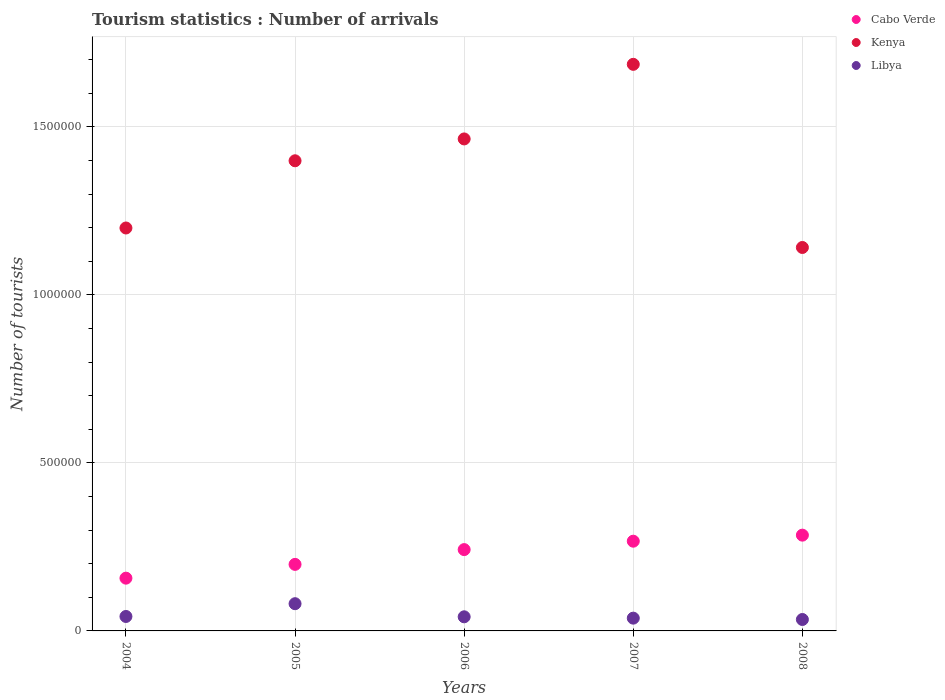Is the number of dotlines equal to the number of legend labels?
Your answer should be compact. Yes. What is the number of tourist arrivals in Libya in 2006?
Ensure brevity in your answer.  4.20e+04. Across all years, what is the maximum number of tourist arrivals in Kenya?
Provide a short and direct response. 1.69e+06. Across all years, what is the minimum number of tourist arrivals in Cabo Verde?
Offer a very short reply. 1.57e+05. What is the total number of tourist arrivals in Libya in the graph?
Make the answer very short. 2.38e+05. What is the difference between the number of tourist arrivals in Libya in 2006 and the number of tourist arrivals in Kenya in 2007?
Your answer should be compact. -1.64e+06. What is the average number of tourist arrivals in Kenya per year?
Provide a short and direct response. 1.38e+06. In the year 2006, what is the difference between the number of tourist arrivals in Kenya and number of tourist arrivals in Libya?
Your answer should be compact. 1.42e+06. In how many years, is the number of tourist arrivals in Kenya greater than 1100000?
Make the answer very short. 5. What is the ratio of the number of tourist arrivals in Kenya in 2004 to that in 2006?
Your response must be concise. 0.82. Is the number of tourist arrivals in Cabo Verde in 2006 less than that in 2007?
Keep it short and to the point. Yes. Is the difference between the number of tourist arrivals in Kenya in 2005 and 2007 greater than the difference between the number of tourist arrivals in Libya in 2005 and 2007?
Your answer should be compact. No. What is the difference between the highest and the second highest number of tourist arrivals in Kenya?
Provide a short and direct response. 2.22e+05. What is the difference between the highest and the lowest number of tourist arrivals in Cabo Verde?
Provide a succinct answer. 1.28e+05. In how many years, is the number of tourist arrivals in Kenya greater than the average number of tourist arrivals in Kenya taken over all years?
Your response must be concise. 3. How many dotlines are there?
Your answer should be very brief. 3. How many years are there in the graph?
Ensure brevity in your answer.  5. How are the legend labels stacked?
Keep it short and to the point. Vertical. What is the title of the graph?
Keep it short and to the point. Tourism statistics : Number of arrivals. Does "Niger" appear as one of the legend labels in the graph?
Offer a very short reply. No. What is the label or title of the X-axis?
Offer a terse response. Years. What is the label or title of the Y-axis?
Your response must be concise. Number of tourists. What is the Number of tourists of Cabo Verde in 2004?
Provide a succinct answer. 1.57e+05. What is the Number of tourists of Kenya in 2004?
Make the answer very short. 1.20e+06. What is the Number of tourists in Libya in 2004?
Provide a succinct answer. 4.30e+04. What is the Number of tourists of Cabo Verde in 2005?
Your answer should be compact. 1.98e+05. What is the Number of tourists in Kenya in 2005?
Offer a terse response. 1.40e+06. What is the Number of tourists of Libya in 2005?
Keep it short and to the point. 8.10e+04. What is the Number of tourists of Cabo Verde in 2006?
Keep it short and to the point. 2.42e+05. What is the Number of tourists in Kenya in 2006?
Make the answer very short. 1.46e+06. What is the Number of tourists of Libya in 2006?
Offer a terse response. 4.20e+04. What is the Number of tourists of Cabo Verde in 2007?
Ensure brevity in your answer.  2.67e+05. What is the Number of tourists of Kenya in 2007?
Keep it short and to the point. 1.69e+06. What is the Number of tourists in Libya in 2007?
Ensure brevity in your answer.  3.80e+04. What is the Number of tourists of Cabo Verde in 2008?
Provide a succinct answer. 2.85e+05. What is the Number of tourists in Kenya in 2008?
Offer a very short reply. 1.14e+06. What is the Number of tourists in Libya in 2008?
Make the answer very short. 3.40e+04. Across all years, what is the maximum Number of tourists in Cabo Verde?
Your answer should be compact. 2.85e+05. Across all years, what is the maximum Number of tourists of Kenya?
Give a very brief answer. 1.69e+06. Across all years, what is the maximum Number of tourists in Libya?
Offer a very short reply. 8.10e+04. Across all years, what is the minimum Number of tourists in Cabo Verde?
Ensure brevity in your answer.  1.57e+05. Across all years, what is the minimum Number of tourists of Kenya?
Provide a succinct answer. 1.14e+06. Across all years, what is the minimum Number of tourists in Libya?
Offer a very short reply. 3.40e+04. What is the total Number of tourists of Cabo Verde in the graph?
Offer a terse response. 1.15e+06. What is the total Number of tourists of Kenya in the graph?
Provide a succinct answer. 6.89e+06. What is the total Number of tourists in Libya in the graph?
Your response must be concise. 2.38e+05. What is the difference between the Number of tourists of Cabo Verde in 2004 and that in 2005?
Provide a succinct answer. -4.10e+04. What is the difference between the Number of tourists in Libya in 2004 and that in 2005?
Keep it short and to the point. -3.80e+04. What is the difference between the Number of tourists in Cabo Verde in 2004 and that in 2006?
Your answer should be very brief. -8.50e+04. What is the difference between the Number of tourists in Kenya in 2004 and that in 2006?
Your answer should be compact. -2.65e+05. What is the difference between the Number of tourists in Libya in 2004 and that in 2006?
Provide a short and direct response. 1000. What is the difference between the Number of tourists in Kenya in 2004 and that in 2007?
Offer a terse response. -4.87e+05. What is the difference between the Number of tourists in Cabo Verde in 2004 and that in 2008?
Give a very brief answer. -1.28e+05. What is the difference between the Number of tourists of Kenya in 2004 and that in 2008?
Ensure brevity in your answer.  5.80e+04. What is the difference between the Number of tourists of Libya in 2004 and that in 2008?
Your answer should be very brief. 9000. What is the difference between the Number of tourists of Cabo Verde in 2005 and that in 2006?
Provide a succinct answer. -4.40e+04. What is the difference between the Number of tourists in Kenya in 2005 and that in 2006?
Provide a succinct answer. -6.50e+04. What is the difference between the Number of tourists of Libya in 2005 and that in 2006?
Offer a terse response. 3.90e+04. What is the difference between the Number of tourists in Cabo Verde in 2005 and that in 2007?
Give a very brief answer. -6.90e+04. What is the difference between the Number of tourists of Kenya in 2005 and that in 2007?
Provide a succinct answer. -2.87e+05. What is the difference between the Number of tourists of Libya in 2005 and that in 2007?
Provide a short and direct response. 4.30e+04. What is the difference between the Number of tourists in Cabo Verde in 2005 and that in 2008?
Offer a terse response. -8.70e+04. What is the difference between the Number of tourists of Kenya in 2005 and that in 2008?
Give a very brief answer. 2.58e+05. What is the difference between the Number of tourists of Libya in 2005 and that in 2008?
Provide a succinct answer. 4.70e+04. What is the difference between the Number of tourists of Cabo Verde in 2006 and that in 2007?
Your answer should be very brief. -2.50e+04. What is the difference between the Number of tourists in Kenya in 2006 and that in 2007?
Make the answer very short. -2.22e+05. What is the difference between the Number of tourists in Libya in 2006 and that in 2007?
Provide a short and direct response. 4000. What is the difference between the Number of tourists in Cabo Verde in 2006 and that in 2008?
Provide a succinct answer. -4.30e+04. What is the difference between the Number of tourists in Kenya in 2006 and that in 2008?
Your response must be concise. 3.23e+05. What is the difference between the Number of tourists of Libya in 2006 and that in 2008?
Your response must be concise. 8000. What is the difference between the Number of tourists of Cabo Verde in 2007 and that in 2008?
Your answer should be very brief. -1.80e+04. What is the difference between the Number of tourists in Kenya in 2007 and that in 2008?
Your answer should be very brief. 5.45e+05. What is the difference between the Number of tourists of Libya in 2007 and that in 2008?
Keep it short and to the point. 4000. What is the difference between the Number of tourists of Cabo Verde in 2004 and the Number of tourists of Kenya in 2005?
Provide a succinct answer. -1.24e+06. What is the difference between the Number of tourists in Cabo Verde in 2004 and the Number of tourists in Libya in 2005?
Ensure brevity in your answer.  7.60e+04. What is the difference between the Number of tourists of Kenya in 2004 and the Number of tourists of Libya in 2005?
Offer a terse response. 1.12e+06. What is the difference between the Number of tourists of Cabo Verde in 2004 and the Number of tourists of Kenya in 2006?
Your answer should be compact. -1.31e+06. What is the difference between the Number of tourists in Cabo Verde in 2004 and the Number of tourists in Libya in 2006?
Offer a very short reply. 1.15e+05. What is the difference between the Number of tourists in Kenya in 2004 and the Number of tourists in Libya in 2006?
Offer a very short reply. 1.16e+06. What is the difference between the Number of tourists in Cabo Verde in 2004 and the Number of tourists in Kenya in 2007?
Your answer should be very brief. -1.53e+06. What is the difference between the Number of tourists in Cabo Verde in 2004 and the Number of tourists in Libya in 2007?
Make the answer very short. 1.19e+05. What is the difference between the Number of tourists of Kenya in 2004 and the Number of tourists of Libya in 2007?
Your answer should be very brief. 1.16e+06. What is the difference between the Number of tourists of Cabo Verde in 2004 and the Number of tourists of Kenya in 2008?
Your response must be concise. -9.84e+05. What is the difference between the Number of tourists in Cabo Verde in 2004 and the Number of tourists in Libya in 2008?
Your answer should be compact. 1.23e+05. What is the difference between the Number of tourists in Kenya in 2004 and the Number of tourists in Libya in 2008?
Your answer should be compact. 1.16e+06. What is the difference between the Number of tourists of Cabo Verde in 2005 and the Number of tourists of Kenya in 2006?
Provide a short and direct response. -1.27e+06. What is the difference between the Number of tourists of Cabo Verde in 2005 and the Number of tourists of Libya in 2006?
Keep it short and to the point. 1.56e+05. What is the difference between the Number of tourists of Kenya in 2005 and the Number of tourists of Libya in 2006?
Offer a very short reply. 1.36e+06. What is the difference between the Number of tourists in Cabo Verde in 2005 and the Number of tourists in Kenya in 2007?
Make the answer very short. -1.49e+06. What is the difference between the Number of tourists of Cabo Verde in 2005 and the Number of tourists of Libya in 2007?
Your response must be concise. 1.60e+05. What is the difference between the Number of tourists in Kenya in 2005 and the Number of tourists in Libya in 2007?
Give a very brief answer. 1.36e+06. What is the difference between the Number of tourists in Cabo Verde in 2005 and the Number of tourists in Kenya in 2008?
Your answer should be very brief. -9.43e+05. What is the difference between the Number of tourists in Cabo Verde in 2005 and the Number of tourists in Libya in 2008?
Give a very brief answer. 1.64e+05. What is the difference between the Number of tourists in Kenya in 2005 and the Number of tourists in Libya in 2008?
Your answer should be very brief. 1.36e+06. What is the difference between the Number of tourists of Cabo Verde in 2006 and the Number of tourists of Kenya in 2007?
Your response must be concise. -1.44e+06. What is the difference between the Number of tourists in Cabo Verde in 2006 and the Number of tourists in Libya in 2007?
Make the answer very short. 2.04e+05. What is the difference between the Number of tourists of Kenya in 2006 and the Number of tourists of Libya in 2007?
Offer a very short reply. 1.43e+06. What is the difference between the Number of tourists of Cabo Verde in 2006 and the Number of tourists of Kenya in 2008?
Keep it short and to the point. -8.99e+05. What is the difference between the Number of tourists in Cabo Verde in 2006 and the Number of tourists in Libya in 2008?
Offer a terse response. 2.08e+05. What is the difference between the Number of tourists of Kenya in 2006 and the Number of tourists of Libya in 2008?
Ensure brevity in your answer.  1.43e+06. What is the difference between the Number of tourists in Cabo Verde in 2007 and the Number of tourists in Kenya in 2008?
Your answer should be compact. -8.74e+05. What is the difference between the Number of tourists in Cabo Verde in 2007 and the Number of tourists in Libya in 2008?
Your response must be concise. 2.33e+05. What is the difference between the Number of tourists of Kenya in 2007 and the Number of tourists of Libya in 2008?
Provide a short and direct response. 1.65e+06. What is the average Number of tourists of Cabo Verde per year?
Make the answer very short. 2.30e+05. What is the average Number of tourists of Kenya per year?
Your answer should be very brief. 1.38e+06. What is the average Number of tourists of Libya per year?
Provide a succinct answer. 4.76e+04. In the year 2004, what is the difference between the Number of tourists in Cabo Verde and Number of tourists in Kenya?
Keep it short and to the point. -1.04e+06. In the year 2004, what is the difference between the Number of tourists in Cabo Verde and Number of tourists in Libya?
Provide a short and direct response. 1.14e+05. In the year 2004, what is the difference between the Number of tourists of Kenya and Number of tourists of Libya?
Provide a short and direct response. 1.16e+06. In the year 2005, what is the difference between the Number of tourists in Cabo Verde and Number of tourists in Kenya?
Ensure brevity in your answer.  -1.20e+06. In the year 2005, what is the difference between the Number of tourists of Cabo Verde and Number of tourists of Libya?
Provide a succinct answer. 1.17e+05. In the year 2005, what is the difference between the Number of tourists in Kenya and Number of tourists in Libya?
Provide a short and direct response. 1.32e+06. In the year 2006, what is the difference between the Number of tourists of Cabo Verde and Number of tourists of Kenya?
Provide a succinct answer. -1.22e+06. In the year 2006, what is the difference between the Number of tourists of Kenya and Number of tourists of Libya?
Provide a succinct answer. 1.42e+06. In the year 2007, what is the difference between the Number of tourists of Cabo Verde and Number of tourists of Kenya?
Make the answer very short. -1.42e+06. In the year 2007, what is the difference between the Number of tourists of Cabo Verde and Number of tourists of Libya?
Give a very brief answer. 2.29e+05. In the year 2007, what is the difference between the Number of tourists in Kenya and Number of tourists in Libya?
Your response must be concise. 1.65e+06. In the year 2008, what is the difference between the Number of tourists in Cabo Verde and Number of tourists in Kenya?
Provide a succinct answer. -8.56e+05. In the year 2008, what is the difference between the Number of tourists in Cabo Verde and Number of tourists in Libya?
Your answer should be compact. 2.51e+05. In the year 2008, what is the difference between the Number of tourists in Kenya and Number of tourists in Libya?
Keep it short and to the point. 1.11e+06. What is the ratio of the Number of tourists in Cabo Verde in 2004 to that in 2005?
Give a very brief answer. 0.79. What is the ratio of the Number of tourists of Kenya in 2004 to that in 2005?
Provide a succinct answer. 0.86. What is the ratio of the Number of tourists in Libya in 2004 to that in 2005?
Your answer should be compact. 0.53. What is the ratio of the Number of tourists of Cabo Verde in 2004 to that in 2006?
Your response must be concise. 0.65. What is the ratio of the Number of tourists in Kenya in 2004 to that in 2006?
Offer a terse response. 0.82. What is the ratio of the Number of tourists of Libya in 2004 to that in 2006?
Give a very brief answer. 1.02. What is the ratio of the Number of tourists of Cabo Verde in 2004 to that in 2007?
Offer a very short reply. 0.59. What is the ratio of the Number of tourists of Kenya in 2004 to that in 2007?
Keep it short and to the point. 0.71. What is the ratio of the Number of tourists of Libya in 2004 to that in 2007?
Give a very brief answer. 1.13. What is the ratio of the Number of tourists of Cabo Verde in 2004 to that in 2008?
Offer a terse response. 0.55. What is the ratio of the Number of tourists of Kenya in 2004 to that in 2008?
Make the answer very short. 1.05. What is the ratio of the Number of tourists in Libya in 2004 to that in 2008?
Your answer should be very brief. 1.26. What is the ratio of the Number of tourists in Cabo Verde in 2005 to that in 2006?
Keep it short and to the point. 0.82. What is the ratio of the Number of tourists in Kenya in 2005 to that in 2006?
Make the answer very short. 0.96. What is the ratio of the Number of tourists of Libya in 2005 to that in 2006?
Provide a short and direct response. 1.93. What is the ratio of the Number of tourists of Cabo Verde in 2005 to that in 2007?
Provide a succinct answer. 0.74. What is the ratio of the Number of tourists in Kenya in 2005 to that in 2007?
Provide a succinct answer. 0.83. What is the ratio of the Number of tourists of Libya in 2005 to that in 2007?
Keep it short and to the point. 2.13. What is the ratio of the Number of tourists of Cabo Verde in 2005 to that in 2008?
Keep it short and to the point. 0.69. What is the ratio of the Number of tourists of Kenya in 2005 to that in 2008?
Offer a very short reply. 1.23. What is the ratio of the Number of tourists in Libya in 2005 to that in 2008?
Provide a short and direct response. 2.38. What is the ratio of the Number of tourists in Cabo Verde in 2006 to that in 2007?
Offer a very short reply. 0.91. What is the ratio of the Number of tourists of Kenya in 2006 to that in 2007?
Provide a succinct answer. 0.87. What is the ratio of the Number of tourists in Libya in 2006 to that in 2007?
Ensure brevity in your answer.  1.11. What is the ratio of the Number of tourists in Cabo Verde in 2006 to that in 2008?
Keep it short and to the point. 0.85. What is the ratio of the Number of tourists of Kenya in 2006 to that in 2008?
Your response must be concise. 1.28. What is the ratio of the Number of tourists of Libya in 2006 to that in 2008?
Ensure brevity in your answer.  1.24. What is the ratio of the Number of tourists in Cabo Verde in 2007 to that in 2008?
Provide a short and direct response. 0.94. What is the ratio of the Number of tourists of Kenya in 2007 to that in 2008?
Provide a short and direct response. 1.48. What is the ratio of the Number of tourists in Libya in 2007 to that in 2008?
Your answer should be compact. 1.12. What is the difference between the highest and the second highest Number of tourists in Cabo Verde?
Provide a short and direct response. 1.80e+04. What is the difference between the highest and the second highest Number of tourists in Kenya?
Keep it short and to the point. 2.22e+05. What is the difference between the highest and the second highest Number of tourists of Libya?
Make the answer very short. 3.80e+04. What is the difference between the highest and the lowest Number of tourists in Cabo Verde?
Offer a very short reply. 1.28e+05. What is the difference between the highest and the lowest Number of tourists in Kenya?
Keep it short and to the point. 5.45e+05. What is the difference between the highest and the lowest Number of tourists in Libya?
Offer a very short reply. 4.70e+04. 